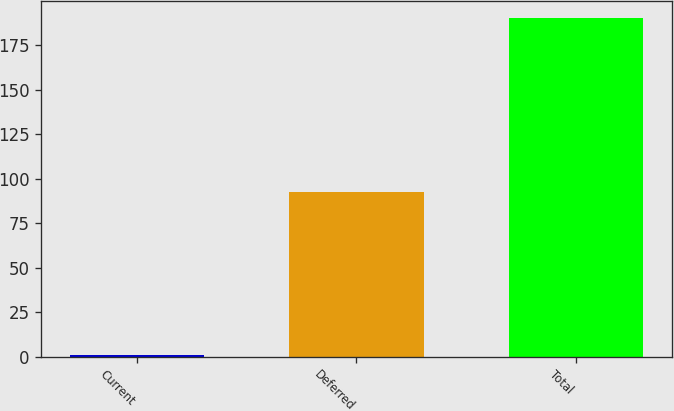Convert chart. <chart><loc_0><loc_0><loc_500><loc_500><bar_chart><fcel>Current<fcel>Deferred<fcel>Total<nl><fcel>0.9<fcel>92.3<fcel>190.2<nl></chart> 